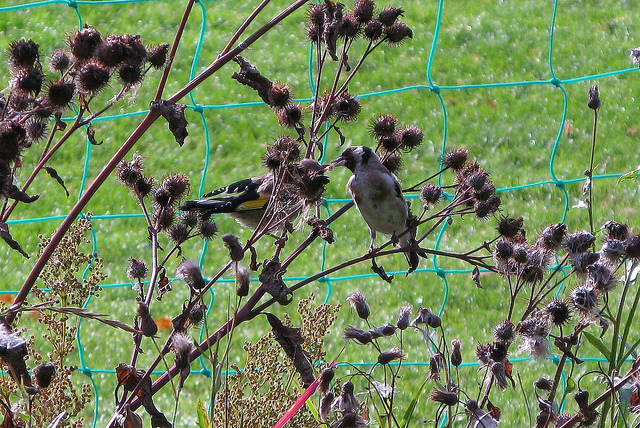What kind of tree is this? Upon careful observation, the plant in the image is not a tree but appears to be burdock, as indicated by the shape and structure of the burs. Burdock is often recognized by its broad leaves and spiky, hook-covered burs that can attach to animal fur and clothing. 